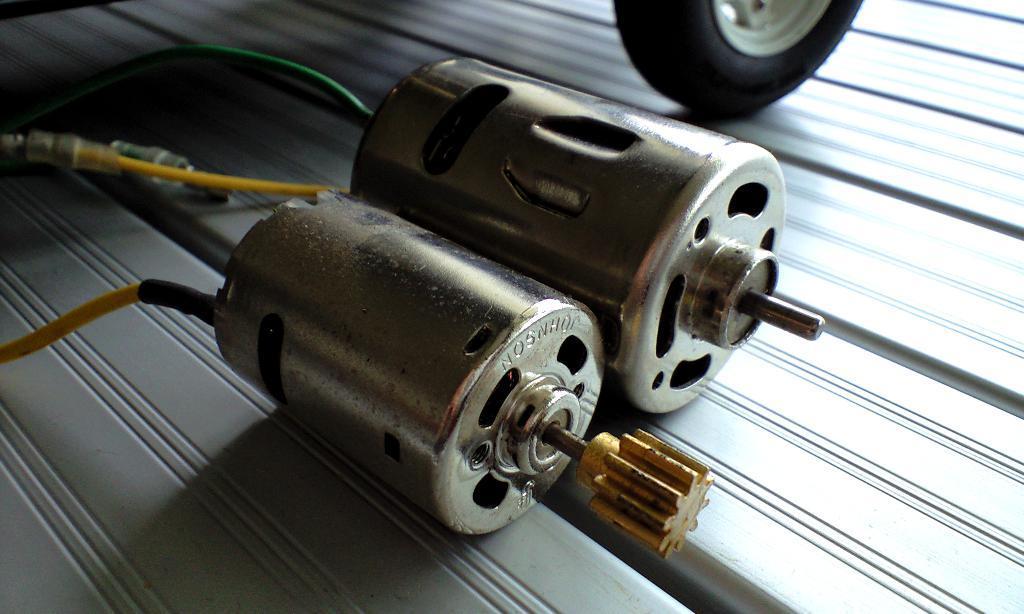Please provide a concise description of this image. In the picture I can see the mini electric motors and wires. There is a Tyre on the top right side of the picture. 